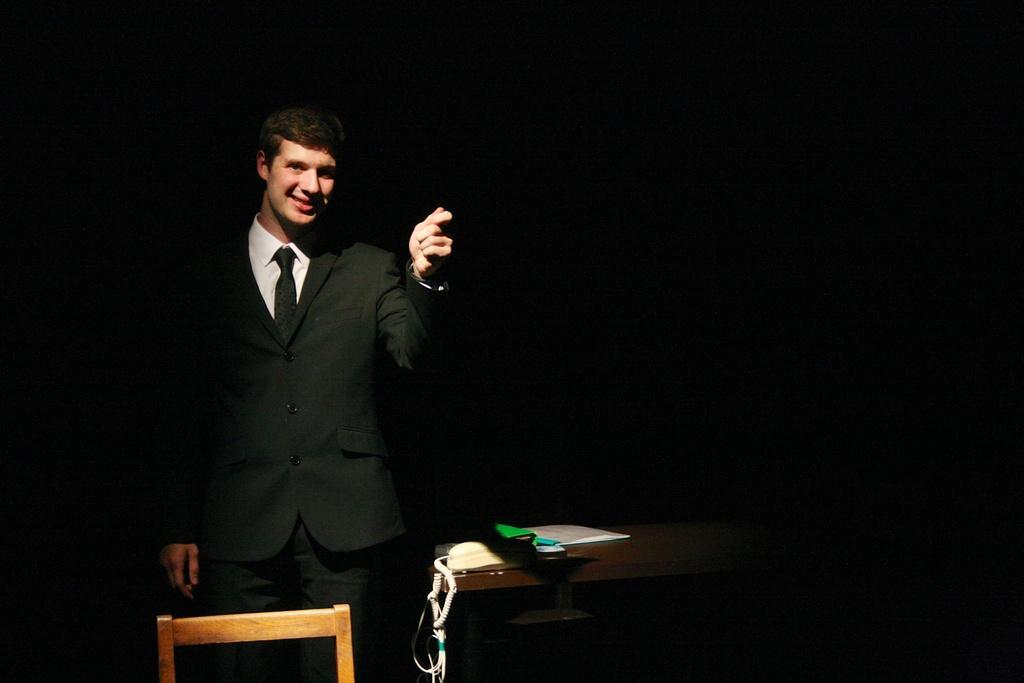How would you summarize this image in a sentence or two? In this picture we can see man wore blazer, tie smiling and standing and beside to him we can see telephone, some book on table and background it is dark. 